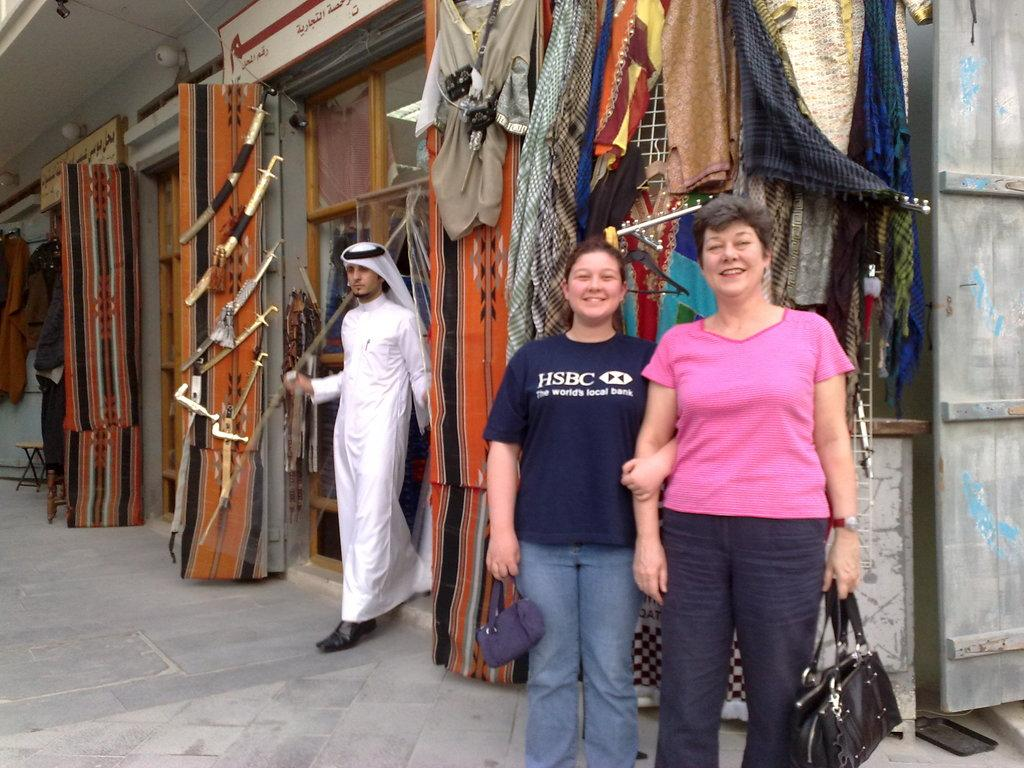How many people are present in the image? There are three people in the image. What are two of the people holding? Two of the people are holding bags. What can be seen in the background of the image? There are many clothes in the background of the image. Where are the weapons located in the image? There are some weapons visible to the left of the image. What type of answer can be seen in the image? There is no answer present in the image; it is a visual representation of people, bags, clothes, and weapons. What is the primary interest of the people in the image? The image does not provide information about the interests of the people; it only shows their appearance and what they are holding. 